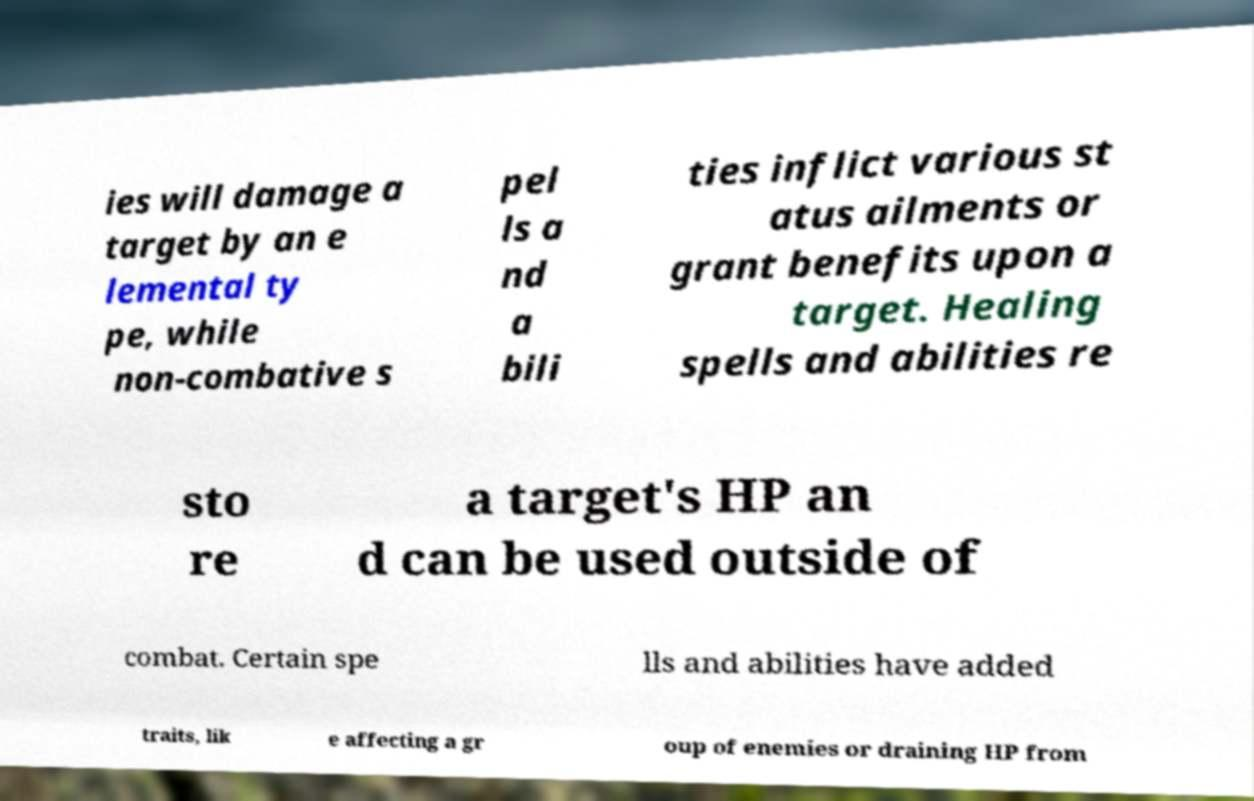Please identify and transcribe the text found in this image. ies will damage a target by an e lemental ty pe, while non-combative s pel ls a nd a bili ties inflict various st atus ailments or grant benefits upon a target. Healing spells and abilities re sto re a target's HP an d can be used outside of combat. Certain spe lls and abilities have added traits, lik e affecting a gr oup of enemies or draining HP from 